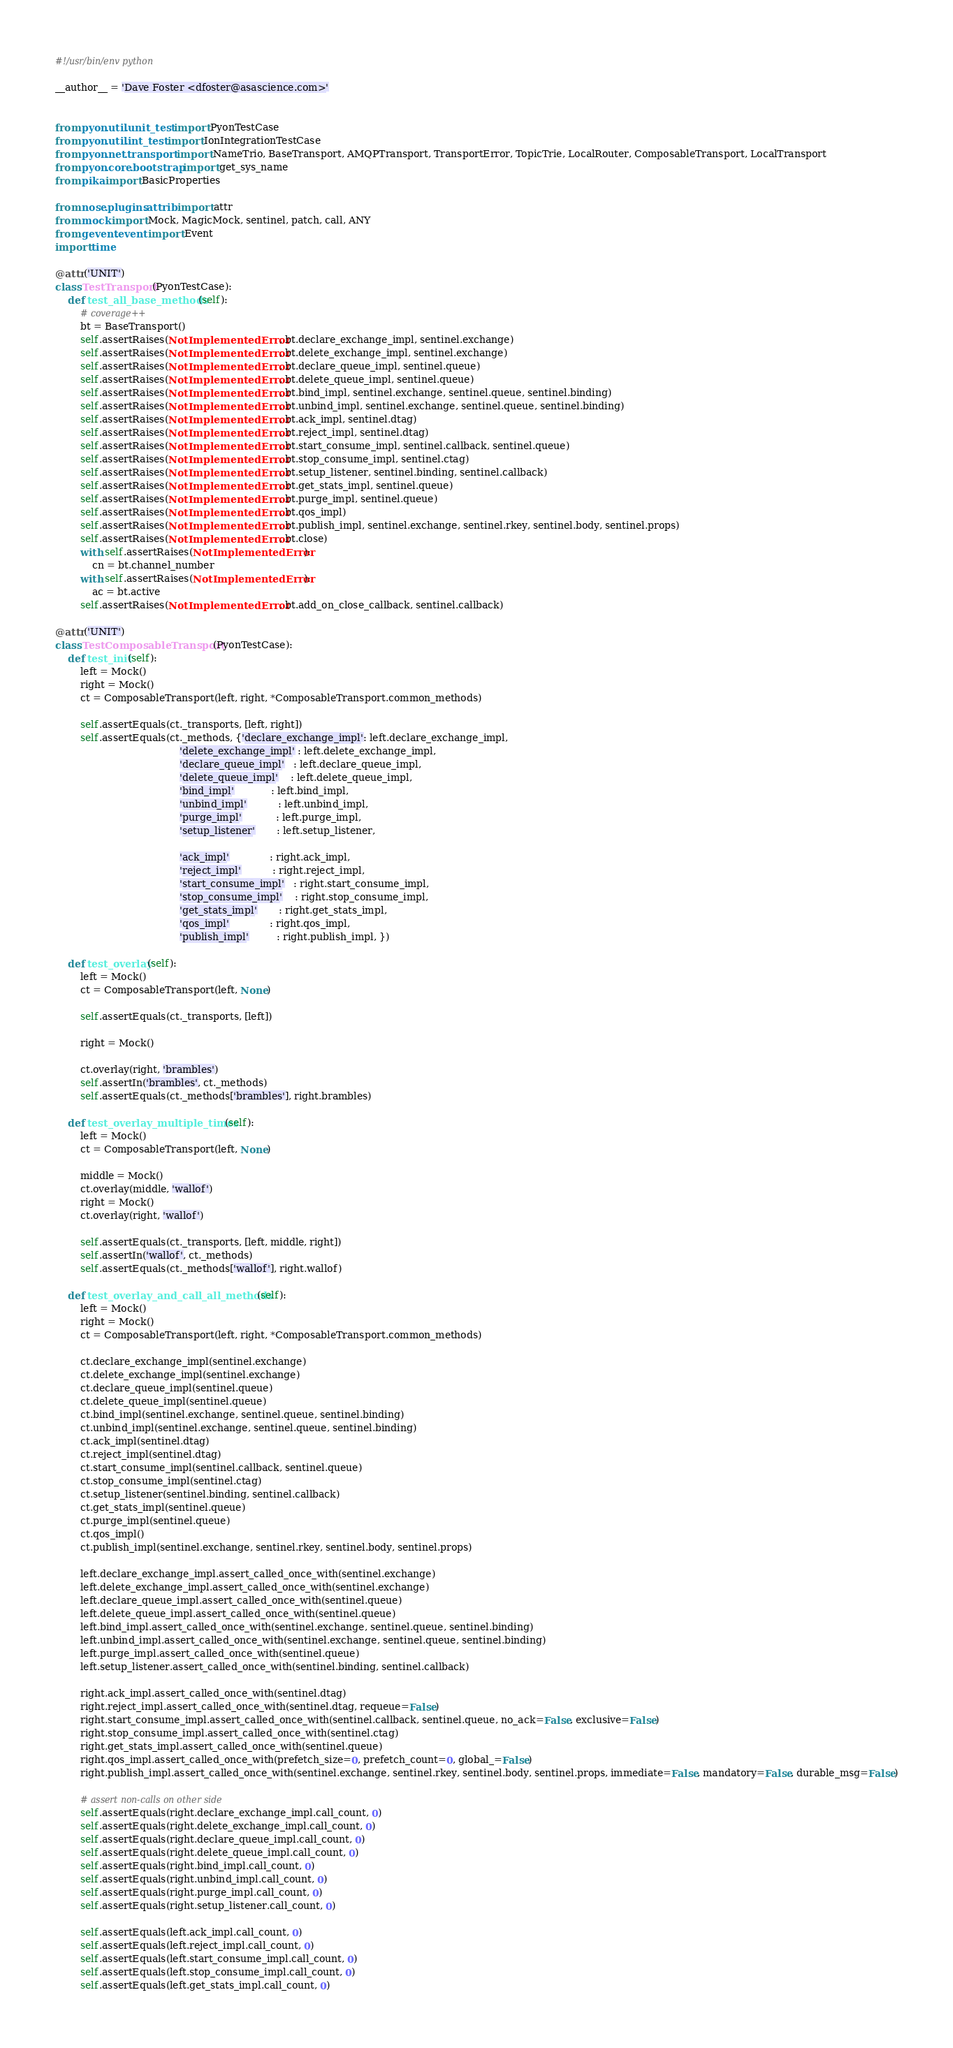Convert code to text. <code><loc_0><loc_0><loc_500><loc_500><_Python_>#!/usr/bin/env python

__author__ = 'Dave Foster <dfoster@asascience.com>'


from pyon.util.unit_test import PyonTestCase
from pyon.util.int_test import IonIntegrationTestCase
from pyon.net.transport import NameTrio, BaseTransport, AMQPTransport, TransportError, TopicTrie, LocalRouter, ComposableTransport, LocalTransport
from pyon.core.bootstrap import get_sys_name
from pika import BasicProperties

from nose.plugins.attrib import attr
from mock import Mock, MagicMock, sentinel, patch, call, ANY
from gevent.event import Event
import time

@attr('UNIT')
class TestTransport(PyonTestCase):
    def test_all_base_methods(self):
        # coverage++
        bt = BaseTransport()
        self.assertRaises(NotImplementedError, bt.declare_exchange_impl, sentinel.exchange)
        self.assertRaises(NotImplementedError, bt.delete_exchange_impl, sentinel.exchange)
        self.assertRaises(NotImplementedError, bt.declare_queue_impl, sentinel.queue)
        self.assertRaises(NotImplementedError, bt.delete_queue_impl, sentinel.queue)
        self.assertRaises(NotImplementedError, bt.bind_impl, sentinel.exchange, sentinel.queue, sentinel.binding)
        self.assertRaises(NotImplementedError, bt.unbind_impl, sentinel.exchange, sentinel.queue, sentinel.binding)
        self.assertRaises(NotImplementedError, bt.ack_impl, sentinel.dtag)
        self.assertRaises(NotImplementedError, bt.reject_impl, sentinel.dtag)
        self.assertRaises(NotImplementedError, bt.start_consume_impl, sentinel.callback, sentinel.queue)
        self.assertRaises(NotImplementedError, bt.stop_consume_impl, sentinel.ctag)
        self.assertRaises(NotImplementedError, bt.setup_listener, sentinel.binding, sentinel.callback)
        self.assertRaises(NotImplementedError, bt.get_stats_impl, sentinel.queue)
        self.assertRaises(NotImplementedError, bt.purge_impl, sentinel.queue)
        self.assertRaises(NotImplementedError, bt.qos_impl)
        self.assertRaises(NotImplementedError, bt.publish_impl, sentinel.exchange, sentinel.rkey, sentinel.body, sentinel.props)
        self.assertRaises(NotImplementedError, bt.close)
        with self.assertRaises(NotImplementedError):
            cn = bt.channel_number
        with self.assertRaises(NotImplementedError):
            ac = bt.active
        self.assertRaises(NotImplementedError, bt.add_on_close_callback, sentinel.callback)

@attr('UNIT')
class TestComposableTransport(PyonTestCase):
    def test_init(self):
        left = Mock()
        right = Mock()
        ct = ComposableTransport(left, right, *ComposableTransport.common_methods)

        self.assertEquals(ct._transports, [left, right])
        self.assertEquals(ct._methods, {'declare_exchange_impl': left.declare_exchange_impl,
                                        'delete_exchange_impl' : left.delete_exchange_impl,
                                        'declare_queue_impl'   : left.declare_queue_impl,
                                        'delete_queue_impl'    : left.delete_queue_impl,
                                        'bind_impl'            : left.bind_impl,
                                        'unbind_impl'          : left.unbind_impl,
                                        'purge_impl'           : left.purge_impl,
                                        'setup_listener'       : left.setup_listener,

                                        'ack_impl'             : right.ack_impl,
                                        'reject_impl'          : right.reject_impl,
                                        'start_consume_impl'   : right.start_consume_impl,
                                        'stop_consume_impl'    : right.stop_consume_impl,
                                        'get_stats_impl'       : right.get_stats_impl,
                                        'qos_impl'             : right.qos_impl,
                                        'publish_impl'         : right.publish_impl, })

    def test_overlay(self):
        left = Mock()
        ct = ComposableTransport(left, None)

        self.assertEquals(ct._transports, [left])

        right = Mock()

        ct.overlay(right, 'brambles')
        self.assertIn('brambles', ct._methods)
        self.assertEquals(ct._methods['brambles'], right.brambles)

    def test_overlay_multiple_times(self):
        left = Mock()
        ct = ComposableTransport(left, None)

        middle = Mock()
        ct.overlay(middle, 'wallof')
        right = Mock()
        ct.overlay(right, 'wallof')

        self.assertEquals(ct._transports, [left, middle, right])
        self.assertIn('wallof', ct._methods)
        self.assertEquals(ct._methods['wallof'], right.wallof)

    def test_overlay_and_call_all_methods(self):
        left = Mock()
        right = Mock()
        ct = ComposableTransport(left, right, *ComposableTransport.common_methods)

        ct.declare_exchange_impl(sentinel.exchange)
        ct.delete_exchange_impl(sentinel.exchange)
        ct.declare_queue_impl(sentinel.queue)
        ct.delete_queue_impl(sentinel.queue)
        ct.bind_impl(sentinel.exchange, sentinel.queue, sentinel.binding)
        ct.unbind_impl(sentinel.exchange, sentinel.queue, sentinel.binding)
        ct.ack_impl(sentinel.dtag)
        ct.reject_impl(sentinel.dtag)
        ct.start_consume_impl(sentinel.callback, sentinel.queue)
        ct.stop_consume_impl(sentinel.ctag)
        ct.setup_listener(sentinel.binding, sentinel.callback)
        ct.get_stats_impl(sentinel.queue)
        ct.purge_impl(sentinel.queue)
        ct.qos_impl()
        ct.publish_impl(sentinel.exchange, sentinel.rkey, sentinel.body, sentinel.props)

        left.declare_exchange_impl.assert_called_once_with(sentinel.exchange)
        left.delete_exchange_impl.assert_called_once_with(sentinel.exchange)
        left.declare_queue_impl.assert_called_once_with(sentinel.queue)
        left.delete_queue_impl.assert_called_once_with(sentinel.queue)
        left.bind_impl.assert_called_once_with(sentinel.exchange, sentinel.queue, sentinel.binding)
        left.unbind_impl.assert_called_once_with(sentinel.exchange, sentinel.queue, sentinel.binding)
        left.purge_impl.assert_called_once_with(sentinel.queue)
        left.setup_listener.assert_called_once_with(sentinel.binding, sentinel.callback)

        right.ack_impl.assert_called_once_with(sentinel.dtag)
        right.reject_impl.assert_called_once_with(sentinel.dtag, requeue=False)
        right.start_consume_impl.assert_called_once_with(sentinel.callback, sentinel.queue, no_ack=False, exclusive=False)
        right.stop_consume_impl.assert_called_once_with(sentinel.ctag)
        right.get_stats_impl.assert_called_once_with(sentinel.queue)
        right.qos_impl.assert_called_once_with(prefetch_size=0, prefetch_count=0, global_=False)
        right.publish_impl.assert_called_once_with(sentinel.exchange, sentinel.rkey, sentinel.body, sentinel.props, immediate=False, mandatory=False, durable_msg=False)

        # assert non-calls on other side
        self.assertEquals(right.declare_exchange_impl.call_count, 0)
        self.assertEquals(right.delete_exchange_impl.call_count, 0)
        self.assertEquals(right.declare_queue_impl.call_count, 0)
        self.assertEquals(right.delete_queue_impl.call_count, 0)
        self.assertEquals(right.bind_impl.call_count, 0)
        self.assertEquals(right.unbind_impl.call_count, 0)
        self.assertEquals(right.purge_impl.call_count, 0)
        self.assertEquals(right.setup_listener.call_count, 0)

        self.assertEquals(left.ack_impl.call_count, 0)
        self.assertEquals(left.reject_impl.call_count, 0)
        self.assertEquals(left.start_consume_impl.call_count, 0)
        self.assertEquals(left.stop_consume_impl.call_count, 0)
        self.assertEquals(left.get_stats_impl.call_count, 0)</code> 